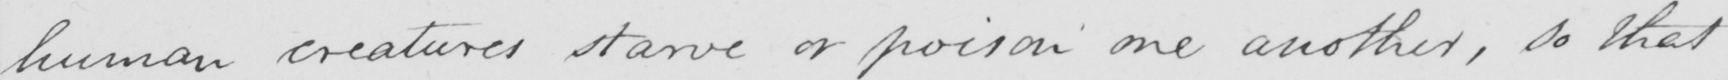What is written in this line of handwriting? human creatures starve or poison one another, so that 